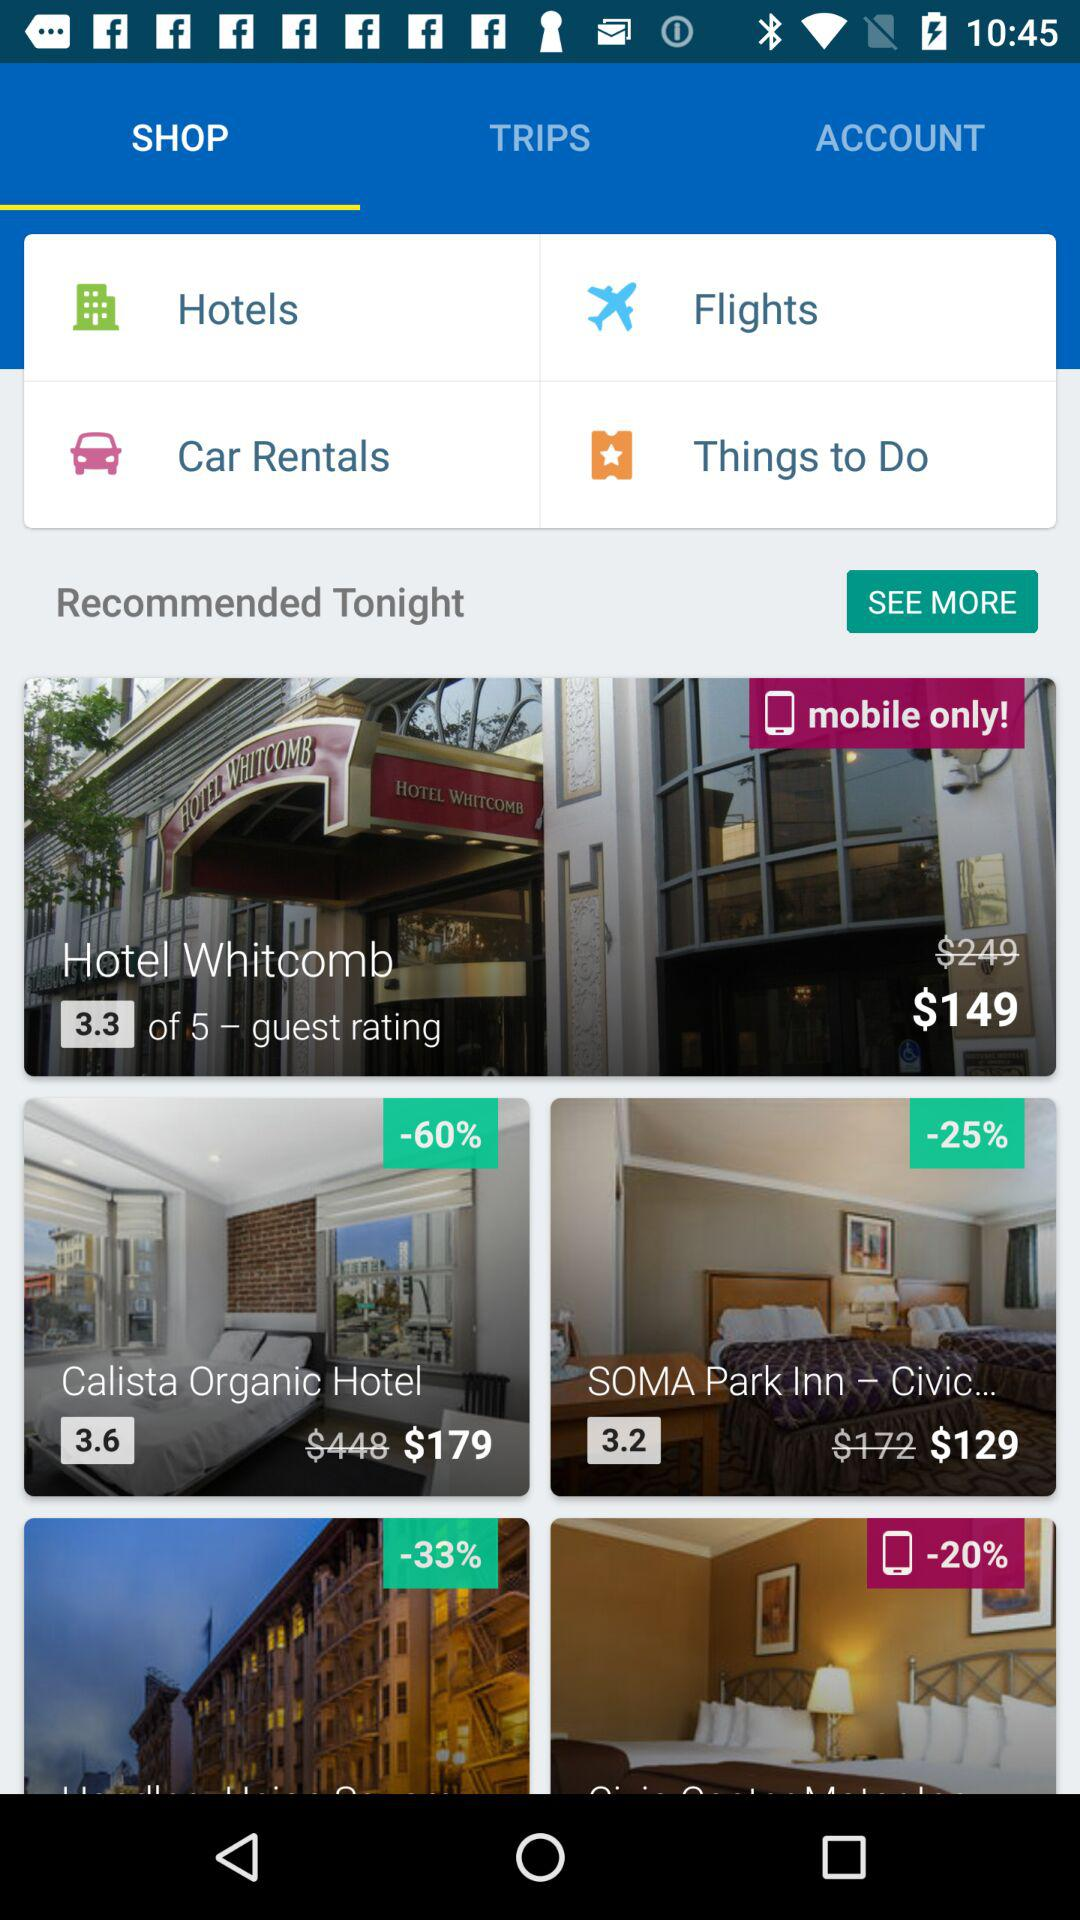What is the name of the hotel with a 3.2 rating? The name of the hotel is "SOMA Park Inn - Civic...". 